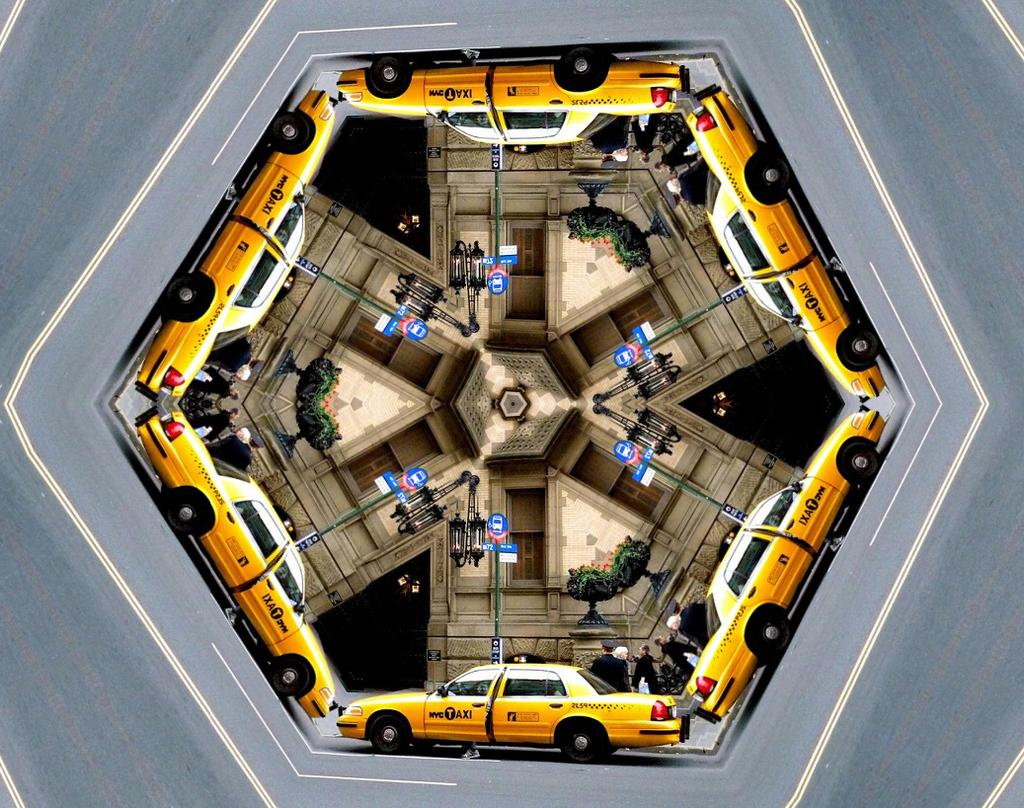What type of vehicle is in the image? There is a yellow taxi car in the image. Where is the taxi car located? The taxi car is on the road. What safety measures are present in the image? There are caution boards in the image. Can you describe the person in the image? There is a person standing in the image. What structure is visible in the image? There is a wall in the image. What is the shape of the image? The image has a hexagon shape. What type of clam is being served at the club in the image? There is no clam or club present in the image; it features a yellow taxi car on the road with caution boards, a person, a wall, and a hexagon shape. 